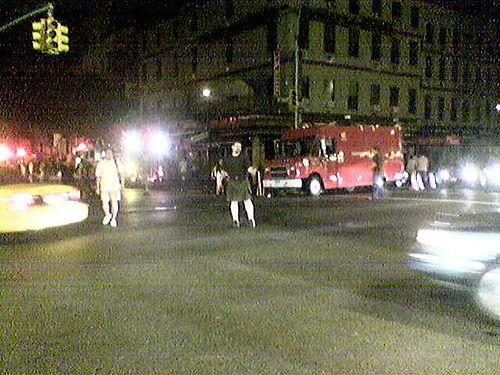Does this look like a good place to take a walk?
Keep it brief. No. Is the picture blurry?
Write a very short answer. Yes. What color is the large truck?
Concise answer only. Red. 